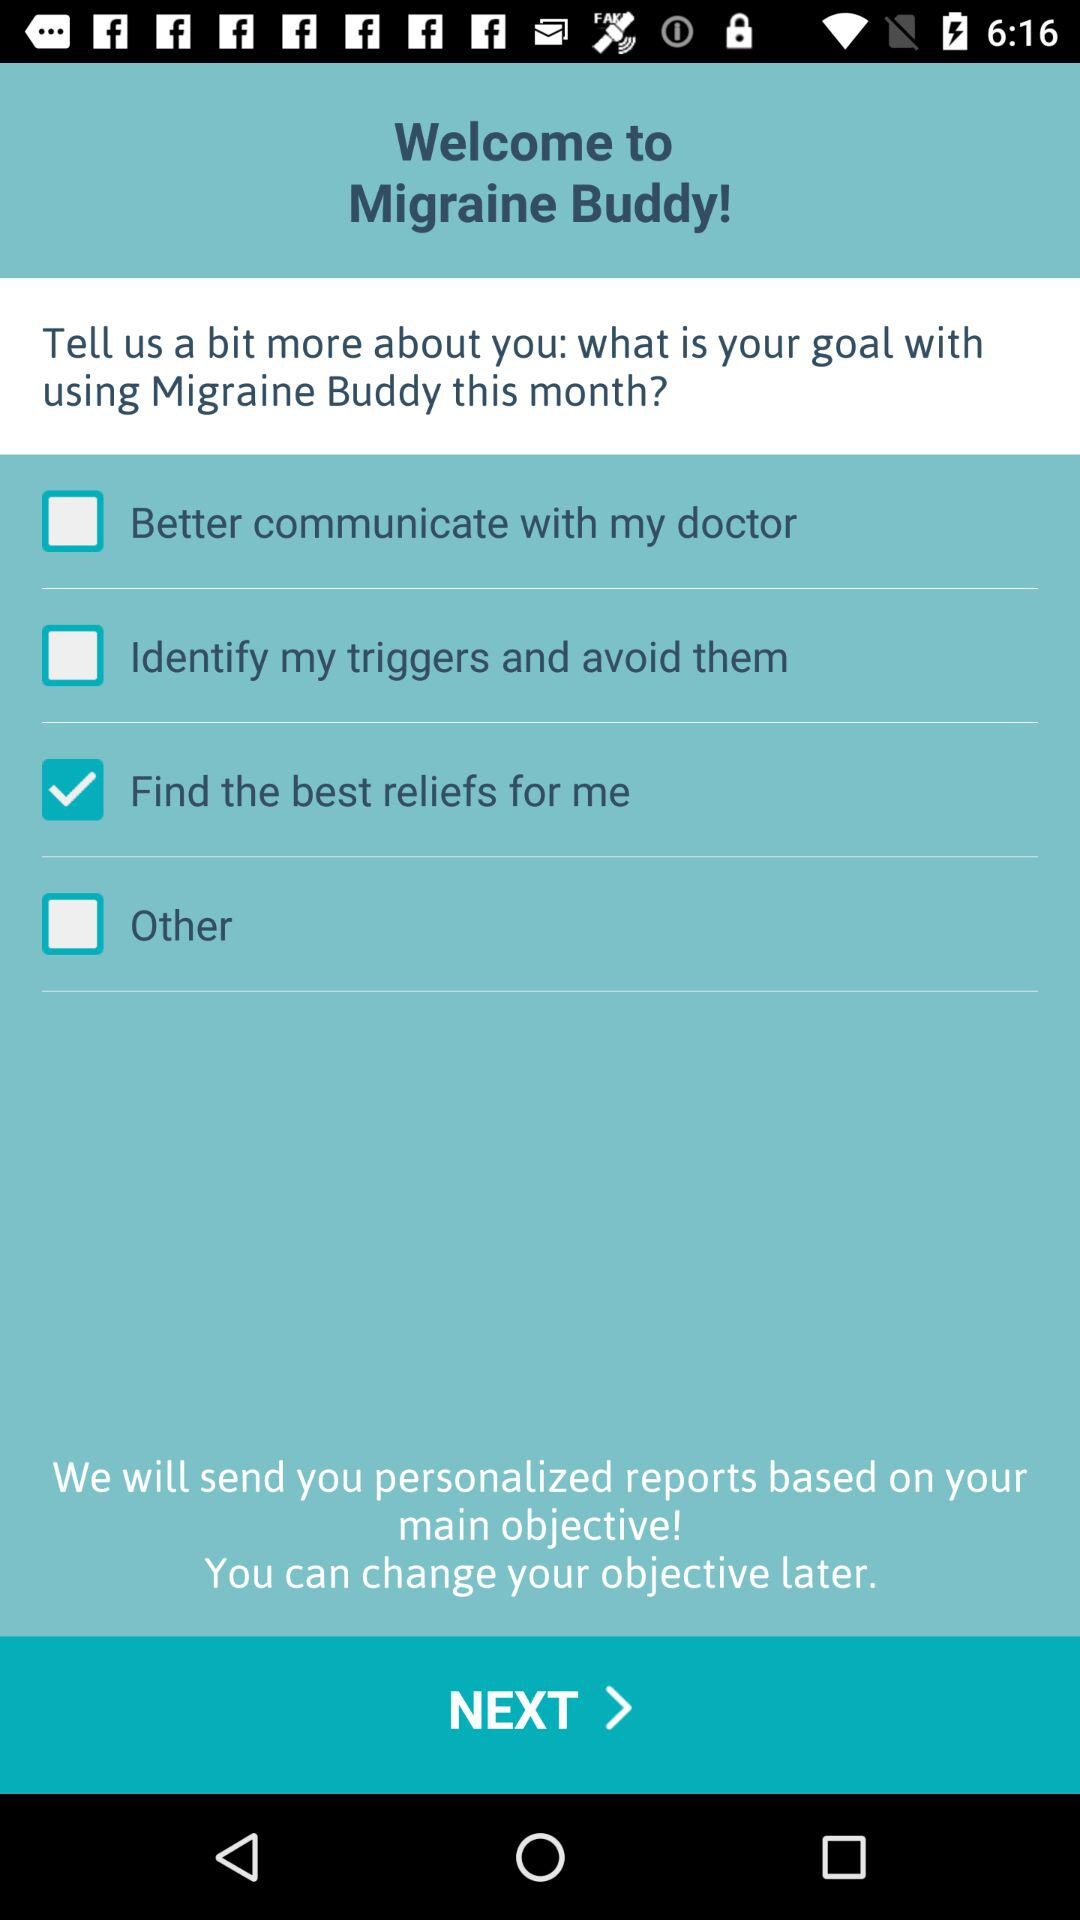Which option is checked? The checked option is "Find the best reliefs for me". 